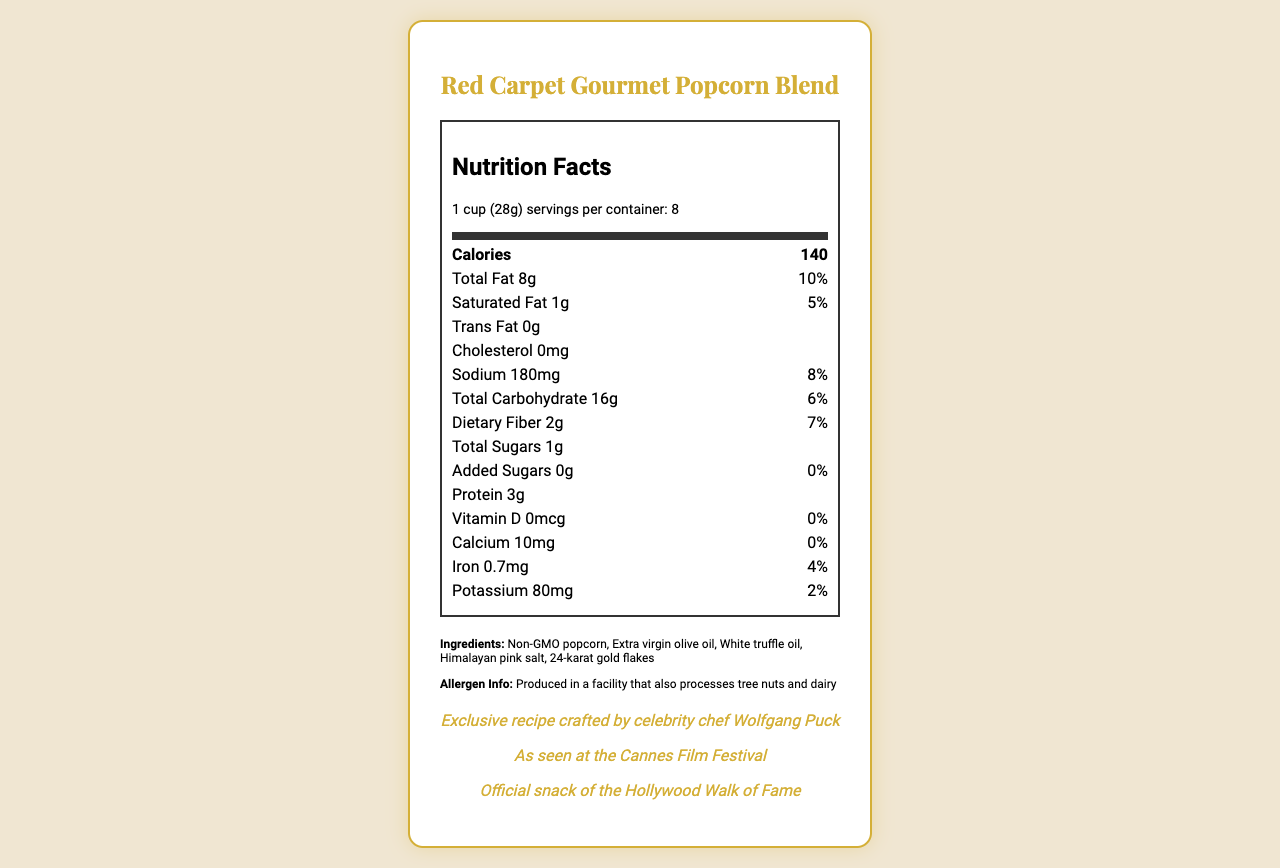what is the serving size? The serving size is listed clearly near the top of the nutrition facts label as "1 cup (28g)".
Answer: 1 cup (28g) how many servings are in a container? The number of servings per container is provided directly below the serving size, indicating there are 8 servings per container.
Answer: 8 what is the amount of total fat per serving? The total fat content per serving is listed as 8g.
Answer: 8g what is the daily value percentage of sodium? The daily value percentage for sodium is provided and is 8%.
Answer: 8% who crafted the exclusive recipe for this popcorn blend? The marketing claims section mentions that the exclusive recipe was crafted by celebrity chef Wolfgang Puck.
Answer: Celebrity chef Wolfgang Puck how much protein does one serving contain? One serving of the popcorn contains 3g of protein, as listed under the nutrition information.
Answer: 3g how much does one 8-oz bag cost? The price point for one 8-oz bag is listed as $49.99.
Answer: $49.99 what is the target audience for this product? The target audience is specified in the additional details and is "Luxury cinema-goers and film industry professionals".
Answer: Luxury cinema-goers and film industry professionals does this product contain any trans fat? The nutrition facts label states that there is 0g of trans fat per serving.
Answer: No what is the total amount of sugars in one serving? The total amount of sugars in one serving is 1g.
Answer: 1g which of the following is NOT an ingredient in this product? 1. Himalayan pink salt 2. 24-karat gold flakes 3. Butter 4. Non-GMO popcorn Butter is not listed as one of the ingredients in this product.
Answer: 3. Butter is the product produced in a facility that processes allergens? The allergen information states that it is produced in a facility that also processes tree nuts and dairy.
Answer: Yes describe the main features listed on the document. The main features listed on the document include the product name, detailed nutrition information per serving, ingredients, allergen information, marketing claims, pricing, and distribution details.
Answer: The document details the nutrition facts for Red Carpet Gourmet Popcorn Blend, including serving size, calories, and amounts of fats, sodium, carbohydrates, dietary fiber, sugars, and protein. It lists ingredients, allergen information, marketing claims, shelf life, packaging details, price point, target audience, distribution channels, and celebrity endorsements. who is the biggest celebrity to have endorsed the product? The document lists several general celebrity endorsements but doesn't specify who the biggest celebrity is.
Answer: Not enough information 